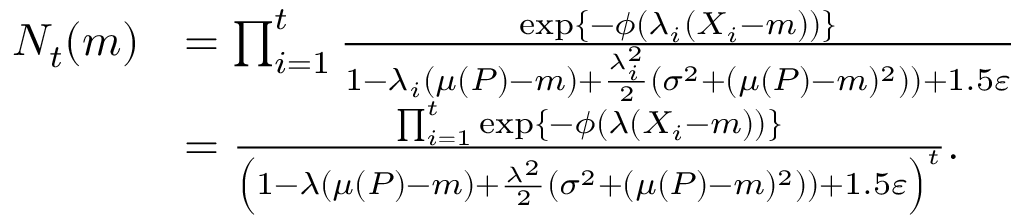<formula> <loc_0><loc_0><loc_500><loc_500>\begin{array} { r l } { N _ { t } ( m ) } & { = \prod _ { i = 1 } ^ { t } \frac { \exp \{ - \phi ( \lambda _ { i } ( X _ { i } - m ) ) \} } { 1 - \lambda _ { i } ( \mu ( P ) - m ) + \frac { \lambda _ { i } ^ { 2 } } { 2 } \left ( \sigma ^ { 2 } + ( \mu ( P ) - m ) ^ { 2 } ) \right ) + 1 . 5 \varepsilon } } \\ & { = \frac { \prod _ { i = 1 } ^ { t } \exp \{ - \phi ( \lambda ( X _ { i } - m ) ) \} } { \left ( 1 - \lambda ( \mu ( P ) - m ) + \frac { \lambda ^ { 2 } } { 2 } \left ( \sigma ^ { 2 } + ( \mu ( P ) - m ) ^ { 2 } ) \right ) + 1 . 5 \varepsilon \right ) ^ { t } } . } \end{array}</formula> 